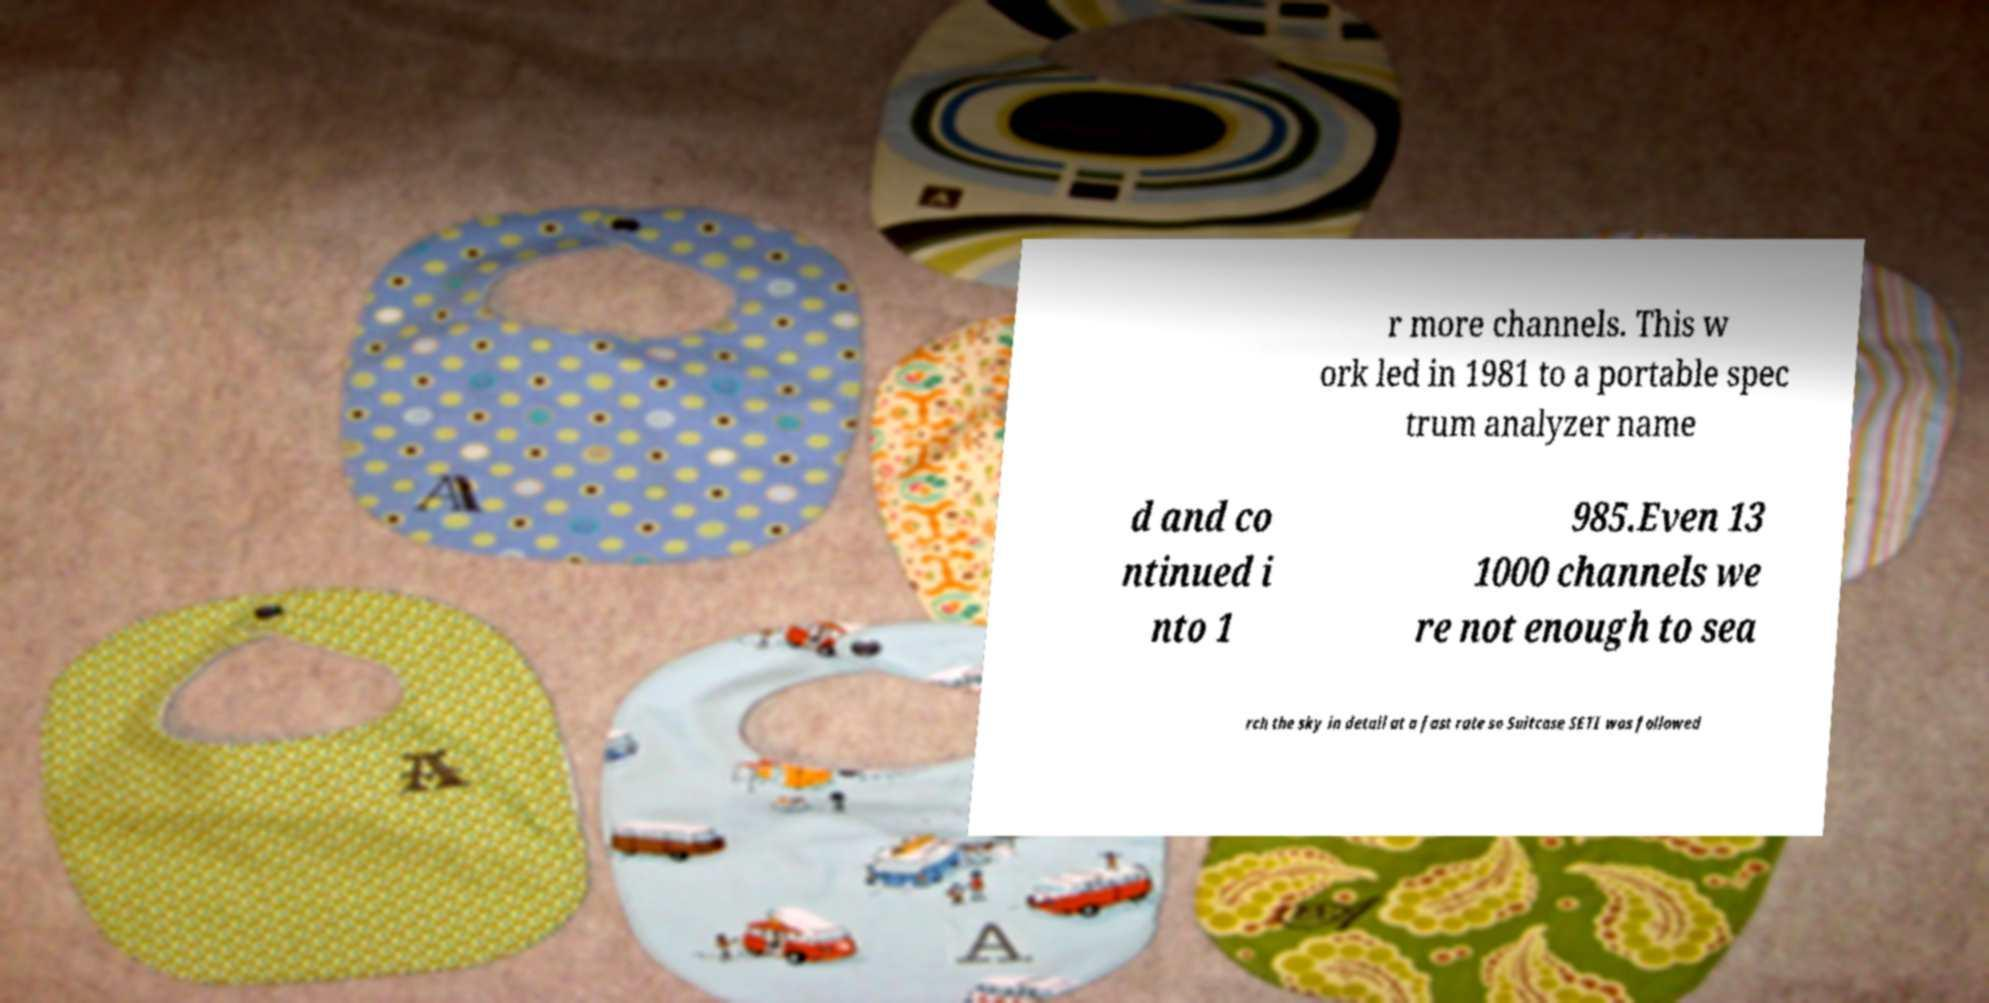Please identify and transcribe the text found in this image. r more channels. This w ork led in 1981 to a portable spec trum analyzer name d and co ntinued i nto 1 985.Even 13 1000 channels we re not enough to sea rch the sky in detail at a fast rate so Suitcase SETI was followed 